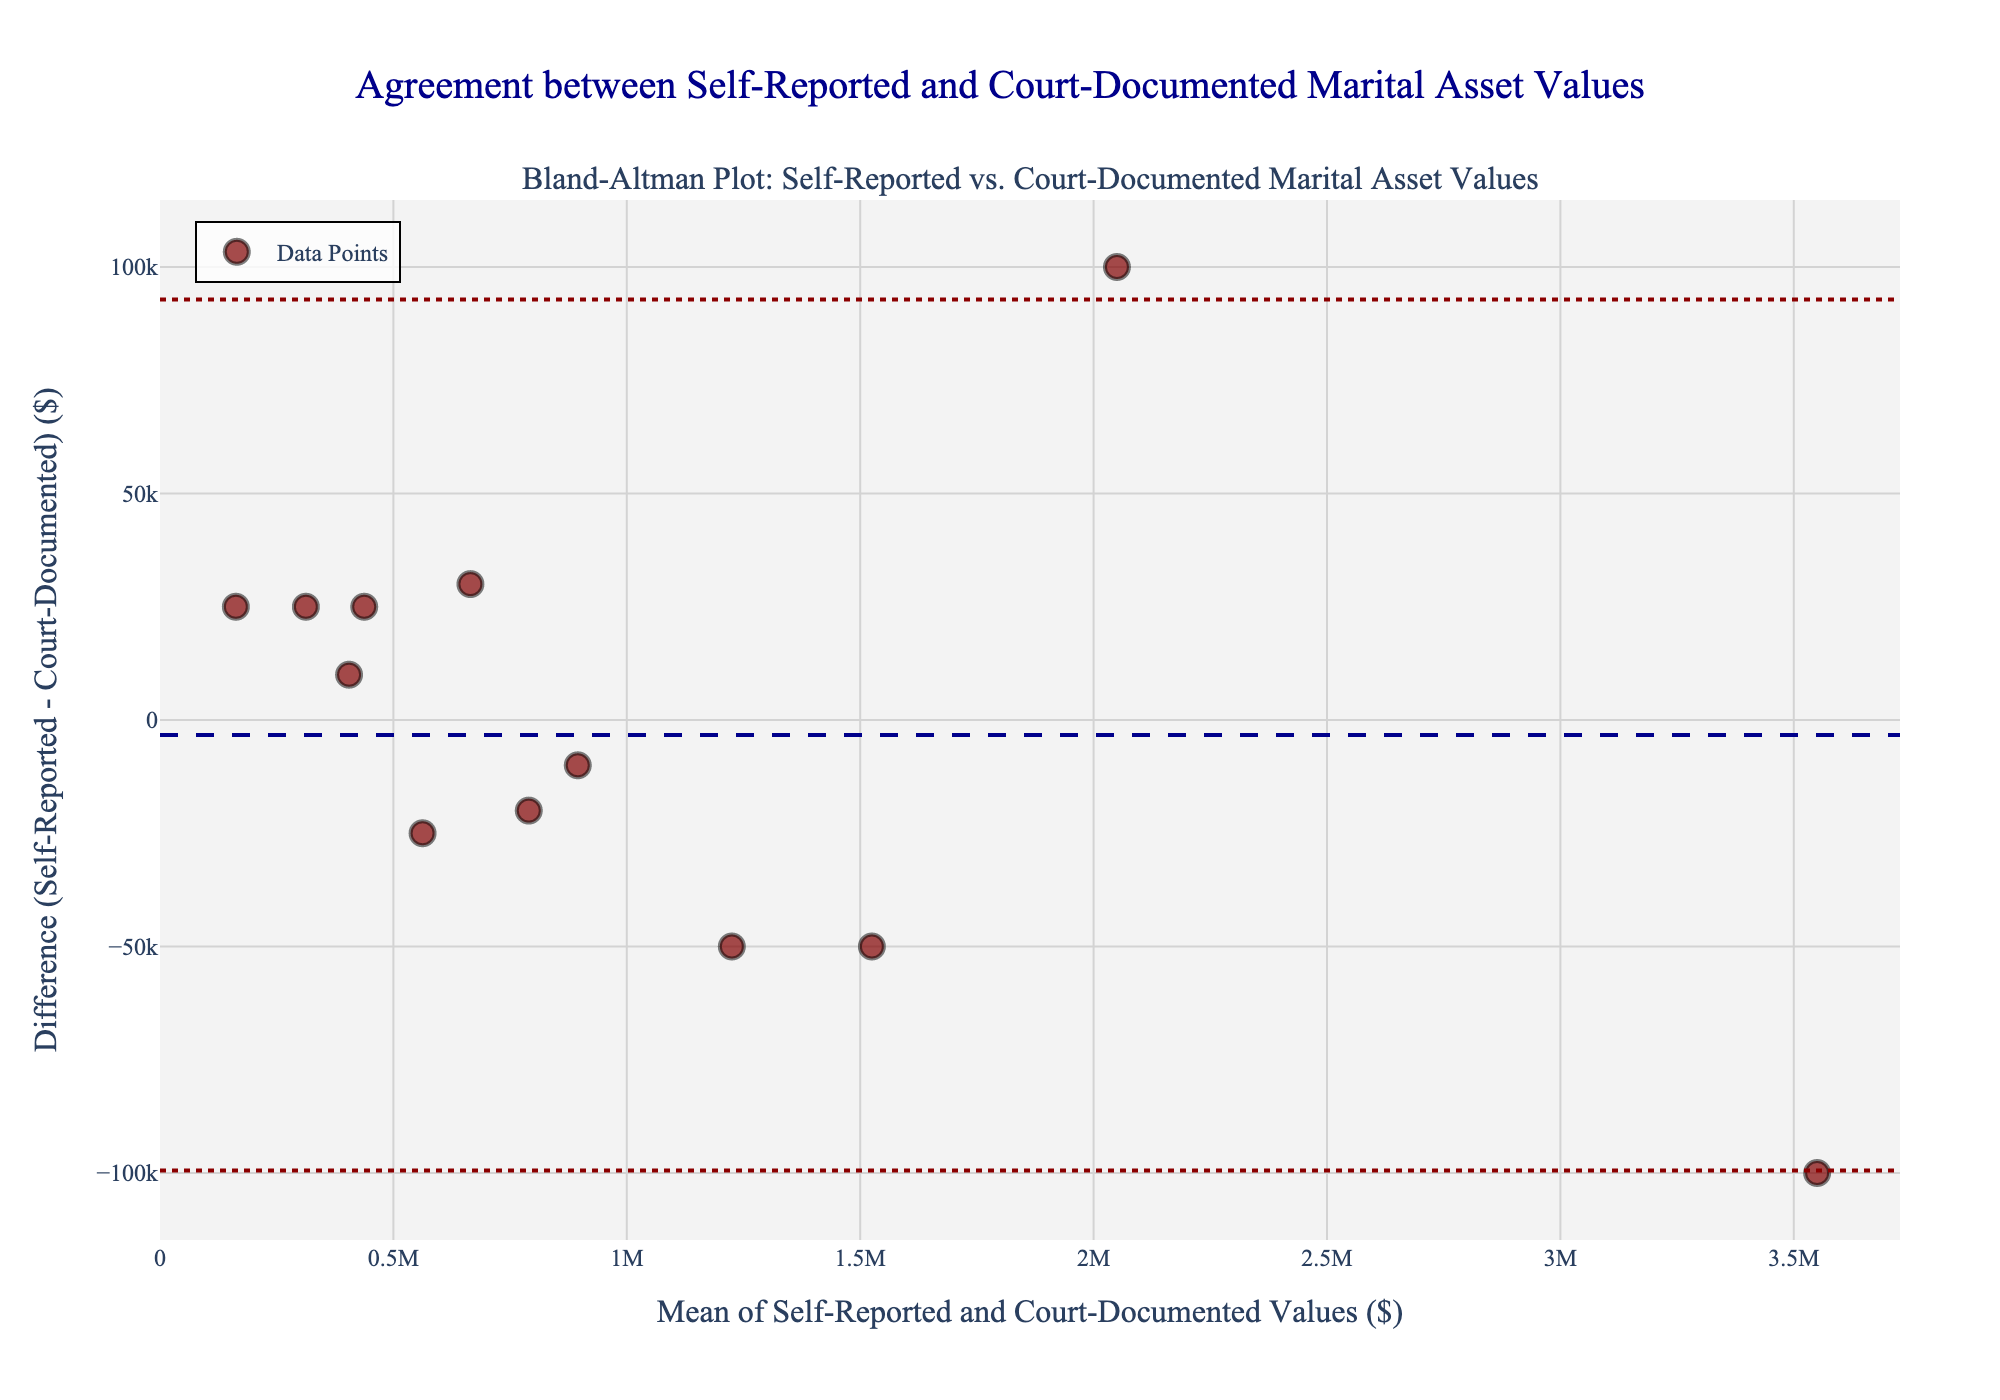How many data points are plotted in the figure? There are 12 data points in the dataset provided. Each row corresponds to one data point representing the mean of self-reported and court-documented values versus their differences.
Answer: 12 What is the title of the plot? The plot title is provided in the code and it aligns with the data context: "Agreement between Self-Reported and Court-Documented Marital Asset Values."
Answer: Agreement between Self-Reported and Court-Documented Marital Asset Values What is the mean of the differences shown in the plot? The mean difference is calculated as the average difference between self-reported and court-documented values for all data points: ((25000) + (-50000) + (-20000) + (25000) + (100000) + (-25000) + (-10000) + (25000) + (-100000) + (30000) + (-50000) + (10000))/12 = (-8333.33). Hence, mean difference is -8333.33.
Answer: -8333.33 Are there more positive or negative differences in the plot? To determine if there are more positive or negative differences, count the number of data points with positive and negative differences. Positive differences: 25000, 25000, 100000, 25000, 30000, 10000 (6 points). Negative differences: -50000, -20000, -25000, -10000, -100000, -50000 (6 points). Hence, they are equal.
Answer: Equal Which point shows the highest absolute difference, and what are the respective self-reported and court-documented values? The highest absolute difference is 100000. This occurs for the data point with self-reported value 2100000 and court-documented value 2000000. To find it, look for the maximum absolute difference in the data provided.
Answer: 2100000 and 2000000 Where is the +1.96 SD line positioned relative to the mean difference? First, calculate the standard deviation of the differences. Standard deviation (SD) is calculated from the differences, then add 1.96 times SD to the mean difference to find the position of +1.96 SD line. Using provided data, SD = 53033; hence 1.96 times SD = 1.96 * 53033 = 103939. Adding to mean difference: -8333.33 + 103939 = 95505.67.
Answer: 95505.67 Do the differences show a pattern as the mean of self-reported and court-documented values increases? From the figure, examine the scatter plot to see if there is any visible trend in the positions of the data points relative to the x-axis. If most points scatter randomly with respect to the mean values without following a specific direction or pattern, then there's no clear trend.
Answer: No clear pattern 